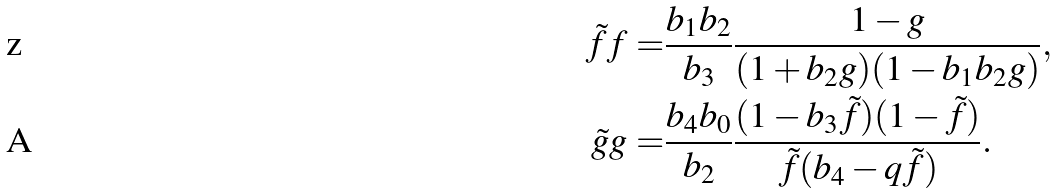Convert formula to latex. <formula><loc_0><loc_0><loc_500><loc_500>\tilde { f } f = & \frac { b _ { 1 } b _ { 2 } } { b _ { 3 } } \frac { 1 - g } { ( 1 + b _ { 2 } g ) ( 1 - b _ { 1 } b _ { 2 } g ) } , \\ \tilde { g } g = & \frac { b _ { 4 } b _ { 0 } } { b _ { 2 } } \frac { ( 1 - b _ { 3 } \tilde { f } ) ( 1 - \tilde { f } ) } { \tilde { f } ( b _ { 4 } - q \tilde { f } ) } .</formula> 